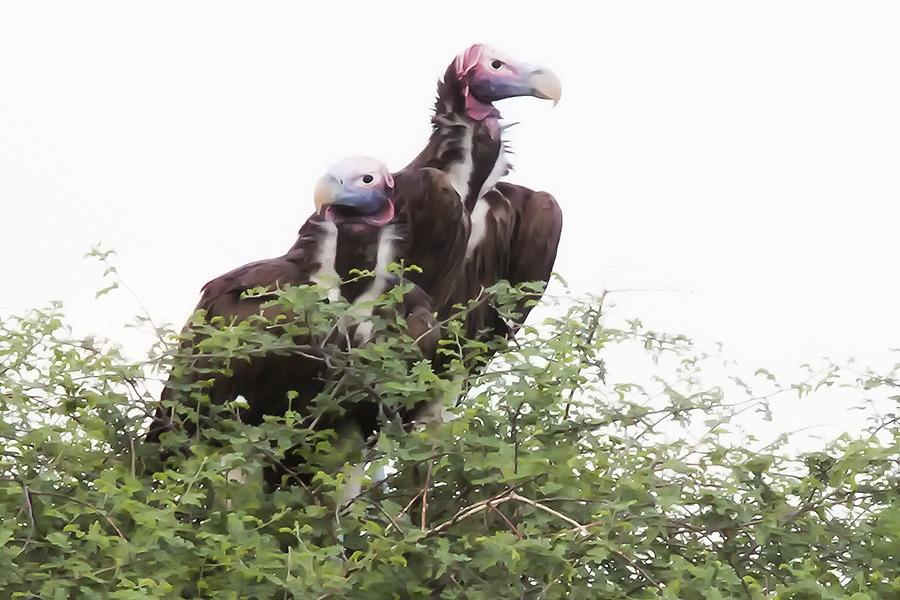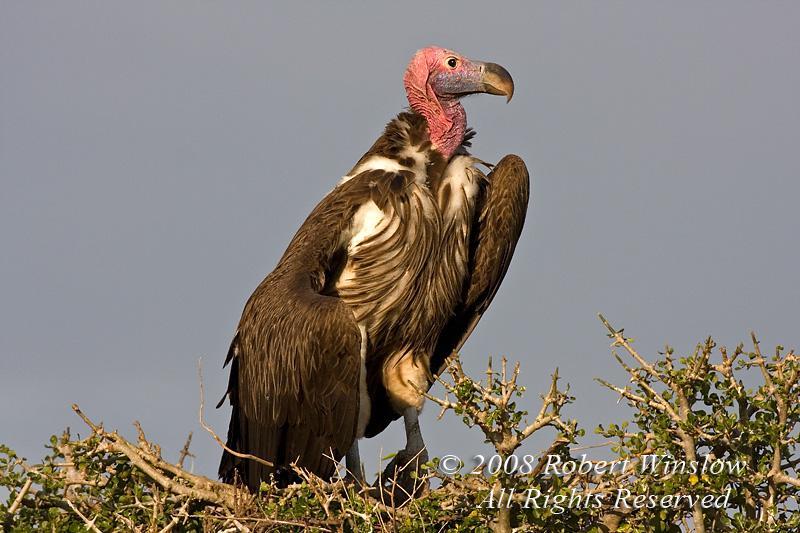The first image is the image on the left, the second image is the image on the right. For the images shown, is this caption "Two birds are perched on a branch in the image on the right." true? Answer yes or no. No. 